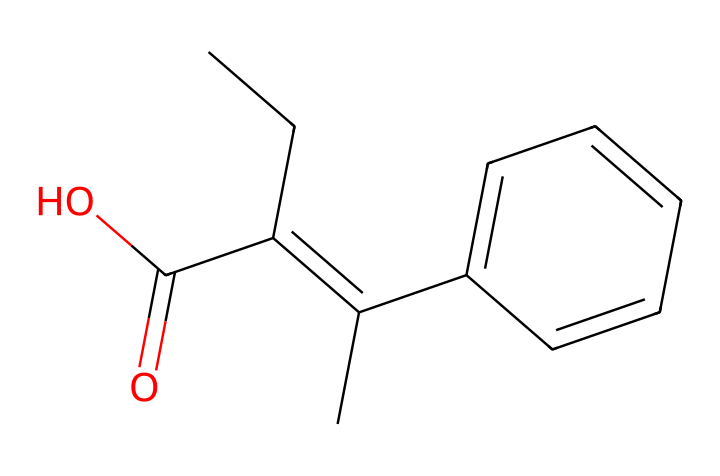What is the molecular formula of this compound? To determine the molecular formula, count the number of each type of atom present in the SMILES representation. By analyzing the structure, there are 15 carbon (C) atoms, 15 hydrogen (H) atoms, and 2 oxygen (O) atoms. Thus, the molecular formula is C15H15O2.
Answer: C15H15O2 How many rings are present in the structure? By examining the visual representation of the SMILES and considering the bonding patterns, it's clear that there are no cyclic structures indicated. Therefore, there are zero rings in this chemical.
Answer: 0 What functional groups can be identified in this drug? Analyzing the structure, one can identify a carboxylic acid (-COOH) functional group due to the presence of the -C(O)=O at one end. Hence, the primary functional group present is a carboxylic acid.
Answer: carboxylic acid What type of compound is this classified as? Given the SMILES indicates the presence of a benzene ring and a specific arrangement of double bonds, this compound is classified as a non-steroidal anti-estrogen, which falls under the category of pharmaceutical drugs.
Answer: non-steroidal anti-estrogen What is the total number of double bonds present? The structure depicted contains two distinct double bonds: one in the central alkene (-C=C-) and another between carbon and oxygen in the carboxylic acid. Therefore, there are a total of two double bonds in this compound.
Answer: 2 How many carbon atoms are connected by single bonds? To identify the number of carbon-carbon single bonds, analyze the structure and count the bonds. There are three regions where carbon atoms are connected by single bonds, specifically around the open chains and the benzene ring. Thus, the total is twelve.
Answer: 12 